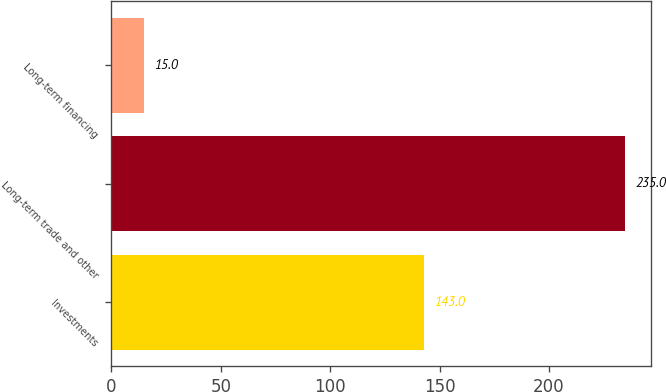<chart> <loc_0><loc_0><loc_500><loc_500><bar_chart><fcel>Investments<fcel>Long-term trade and other<fcel>Long-term financing<nl><fcel>143<fcel>235<fcel>15<nl></chart> 